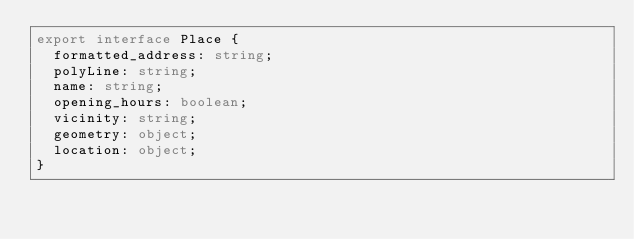Convert code to text. <code><loc_0><loc_0><loc_500><loc_500><_TypeScript_>export interface Place {
  formatted_address: string;
  polyLine: string;
  name: string;
  opening_hours: boolean;
  vicinity: string;
  geometry: object;
  location: object;
}</code> 